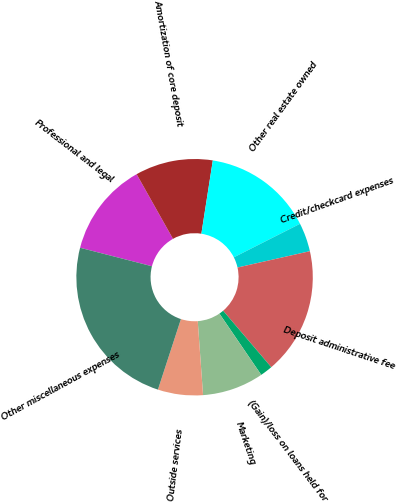<chart> <loc_0><loc_0><loc_500><loc_500><pie_chart><fcel>Professional and legal<fcel>Amortization of core deposit<fcel>Other real estate owned<fcel>Credit/checkcard expenses<fcel>Deposit administrative fee<fcel>(Gain)/loss on loans held for<fcel>Marketing<fcel>Outside services<fcel>Other miscellaneous expenses<nl><fcel>12.84%<fcel>10.62%<fcel>15.07%<fcel>3.93%<fcel>17.3%<fcel>1.7%<fcel>8.39%<fcel>6.16%<fcel>23.99%<nl></chart> 